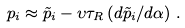<formula> <loc_0><loc_0><loc_500><loc_500>p _ { i } \approx \tilde { p } _ { i } - \upsilon \tau _ { R } \left ( d \tilde { p } _ { i } / d \alpha \right ) \, .</formula> 